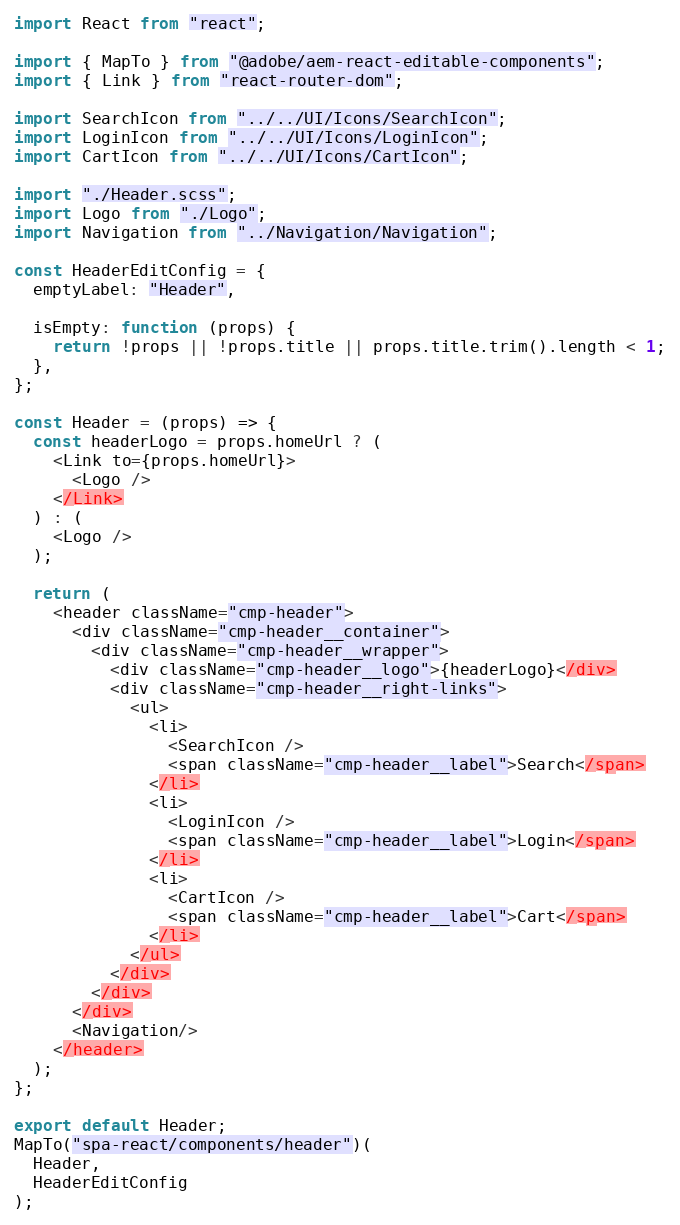Convert code to text. <code><loc_0><loc_0><loc_500><loc_500><_JavaScript_>import React from "react";

import { MapTo } from "@adobe/aem-react-editable-components";
import { Link } from "react-router-dom";

import SearchIcon from "../../UI/Icons/SearchIcon";
import LoginIcon from "../../UI/Icons/LoginIcon";
import CartIcon from "../../UI/Icons/CartIcon";

import "./Header.scss";
import Logo from "./Logo";
import Navigation from "../Navigation/Navigation";

const HeaderEditConfig = {
  emptyLabel: "Header",

  isEmpty: function (props) {
    return !props || !props.title || props.title.trim().length < 1;
  },
};

const Header = (props) => {
  const headerLogo = props.homeUrl ? (
    <Link to={props.homeUrl}>
      <Logo />
    </Link>
  ) : (
    <Logo />
  );

  return (
    <header className="cmp-header">
      <div className="cmp-header__container">
        <div className="cmp-header__wrapper">
          <div className="cmp-header__logo">{headerLogo}</div>
          <div className="cmp-header__right-links">
            <ul>
              <li>
                <SearchIcon />
                <span className="cmp-header__label">Search</span>
              </li>
              <li>
                <LoginIcon />
                <span className="cmp-header__label">Login</span>
              </li>
              <li>
                <CartIcon />
                <span className="cmp-header__label">Cart</span>
              </li>
            </ul>
          </div>
        </div>
      </div>
      <Navigation/>
    </header>
  );
};

export default Header;
MapTo("spa-react/components/header")(
  Header,
  HeaderEditConfig
);
</code> 